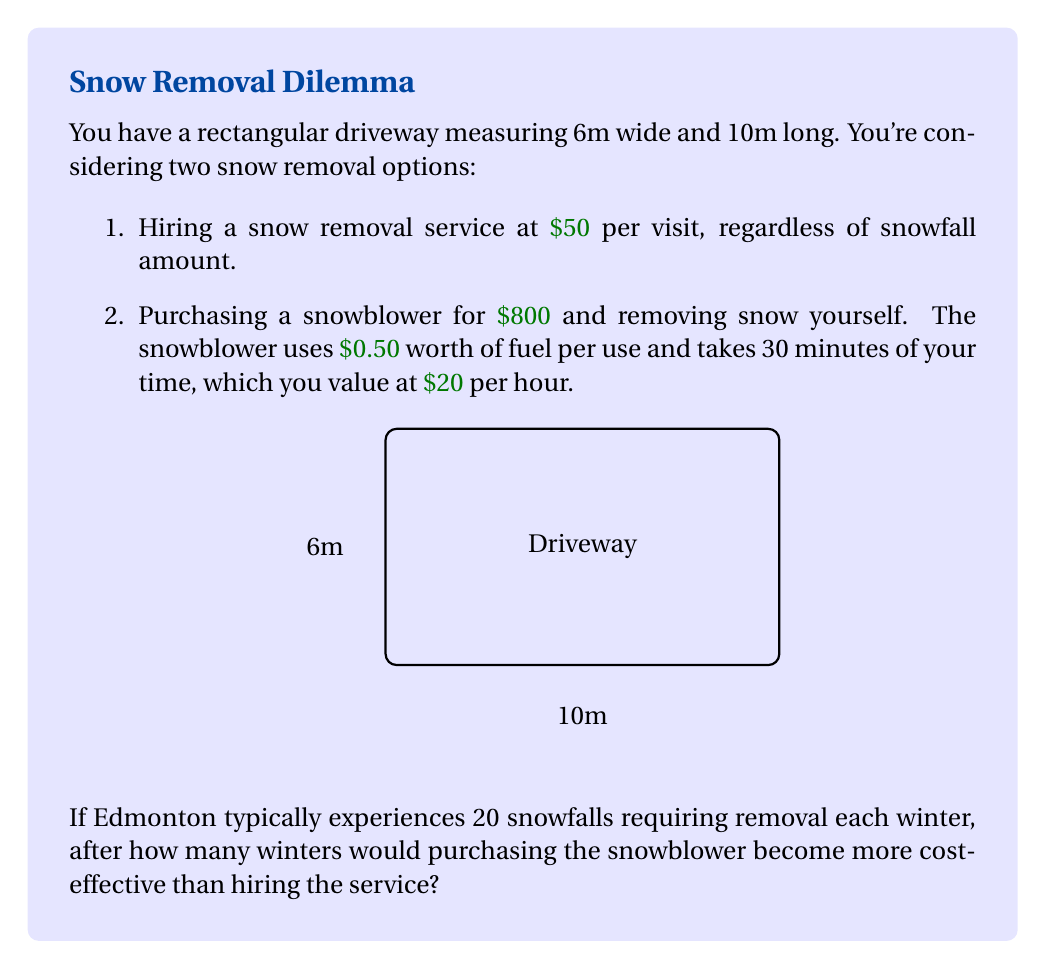Provide a solution to this math problem. Let's approach this step-by-step:

1) First, calculate the annual cost of the snow removal service:
   $$\text{Annual service cost} = 20 \text{ snowfalls} \times \$50 = \$1000$$

2) Now, calculate the annual cost of using the snowblower:
   - Fuel cost per winter: $20 \text{ snowfalls} \times \$0.50 = \$10$
   - Time cost per winter: $20 \text{ snowfalls} \times 0.5 \text{ hours} \times \$20/\text{hour} = \$200$
   - Annual operating cost: $\$10 + \$200 = \$210$

3) Let $x$ be the number of winters. Set up an equation where the total cost of the snowblower equals the total cost of the service:
   $$800 + 210x = 1000x$$

4) Solve for $x$:
   $$800 + 210x = 1000x$$
   $$800 = 790x$$
   $$x = \frac{800}{790} \approx 1.0127$$

5) Since we can't have a fractional winter, we need to round up to the next whole number.

Therefore, after 2 winters, the snowblower becomes more cost-effective.
Answer: 2 winters 